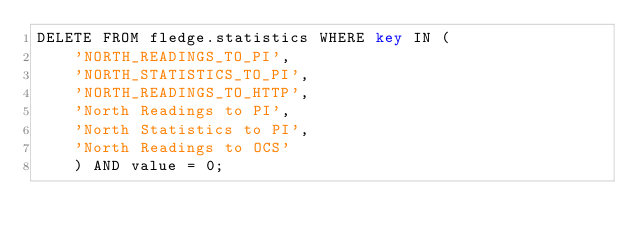<code> <loc_0><loc_0><loc_500><loc_500><_SQL_>DELETE FROM fledge.statistics WHERE key IN (
    'NORTH_READINGS_TO_PI',
    'NORTH_STATISTICS_TO_PI',
    'NORTH_READINGS_TO_HTTP',
    'North Readings to PI',
    'North Statistics to PI',
    'North Readings to OCS'
    ) AND value = 0;
</code> 